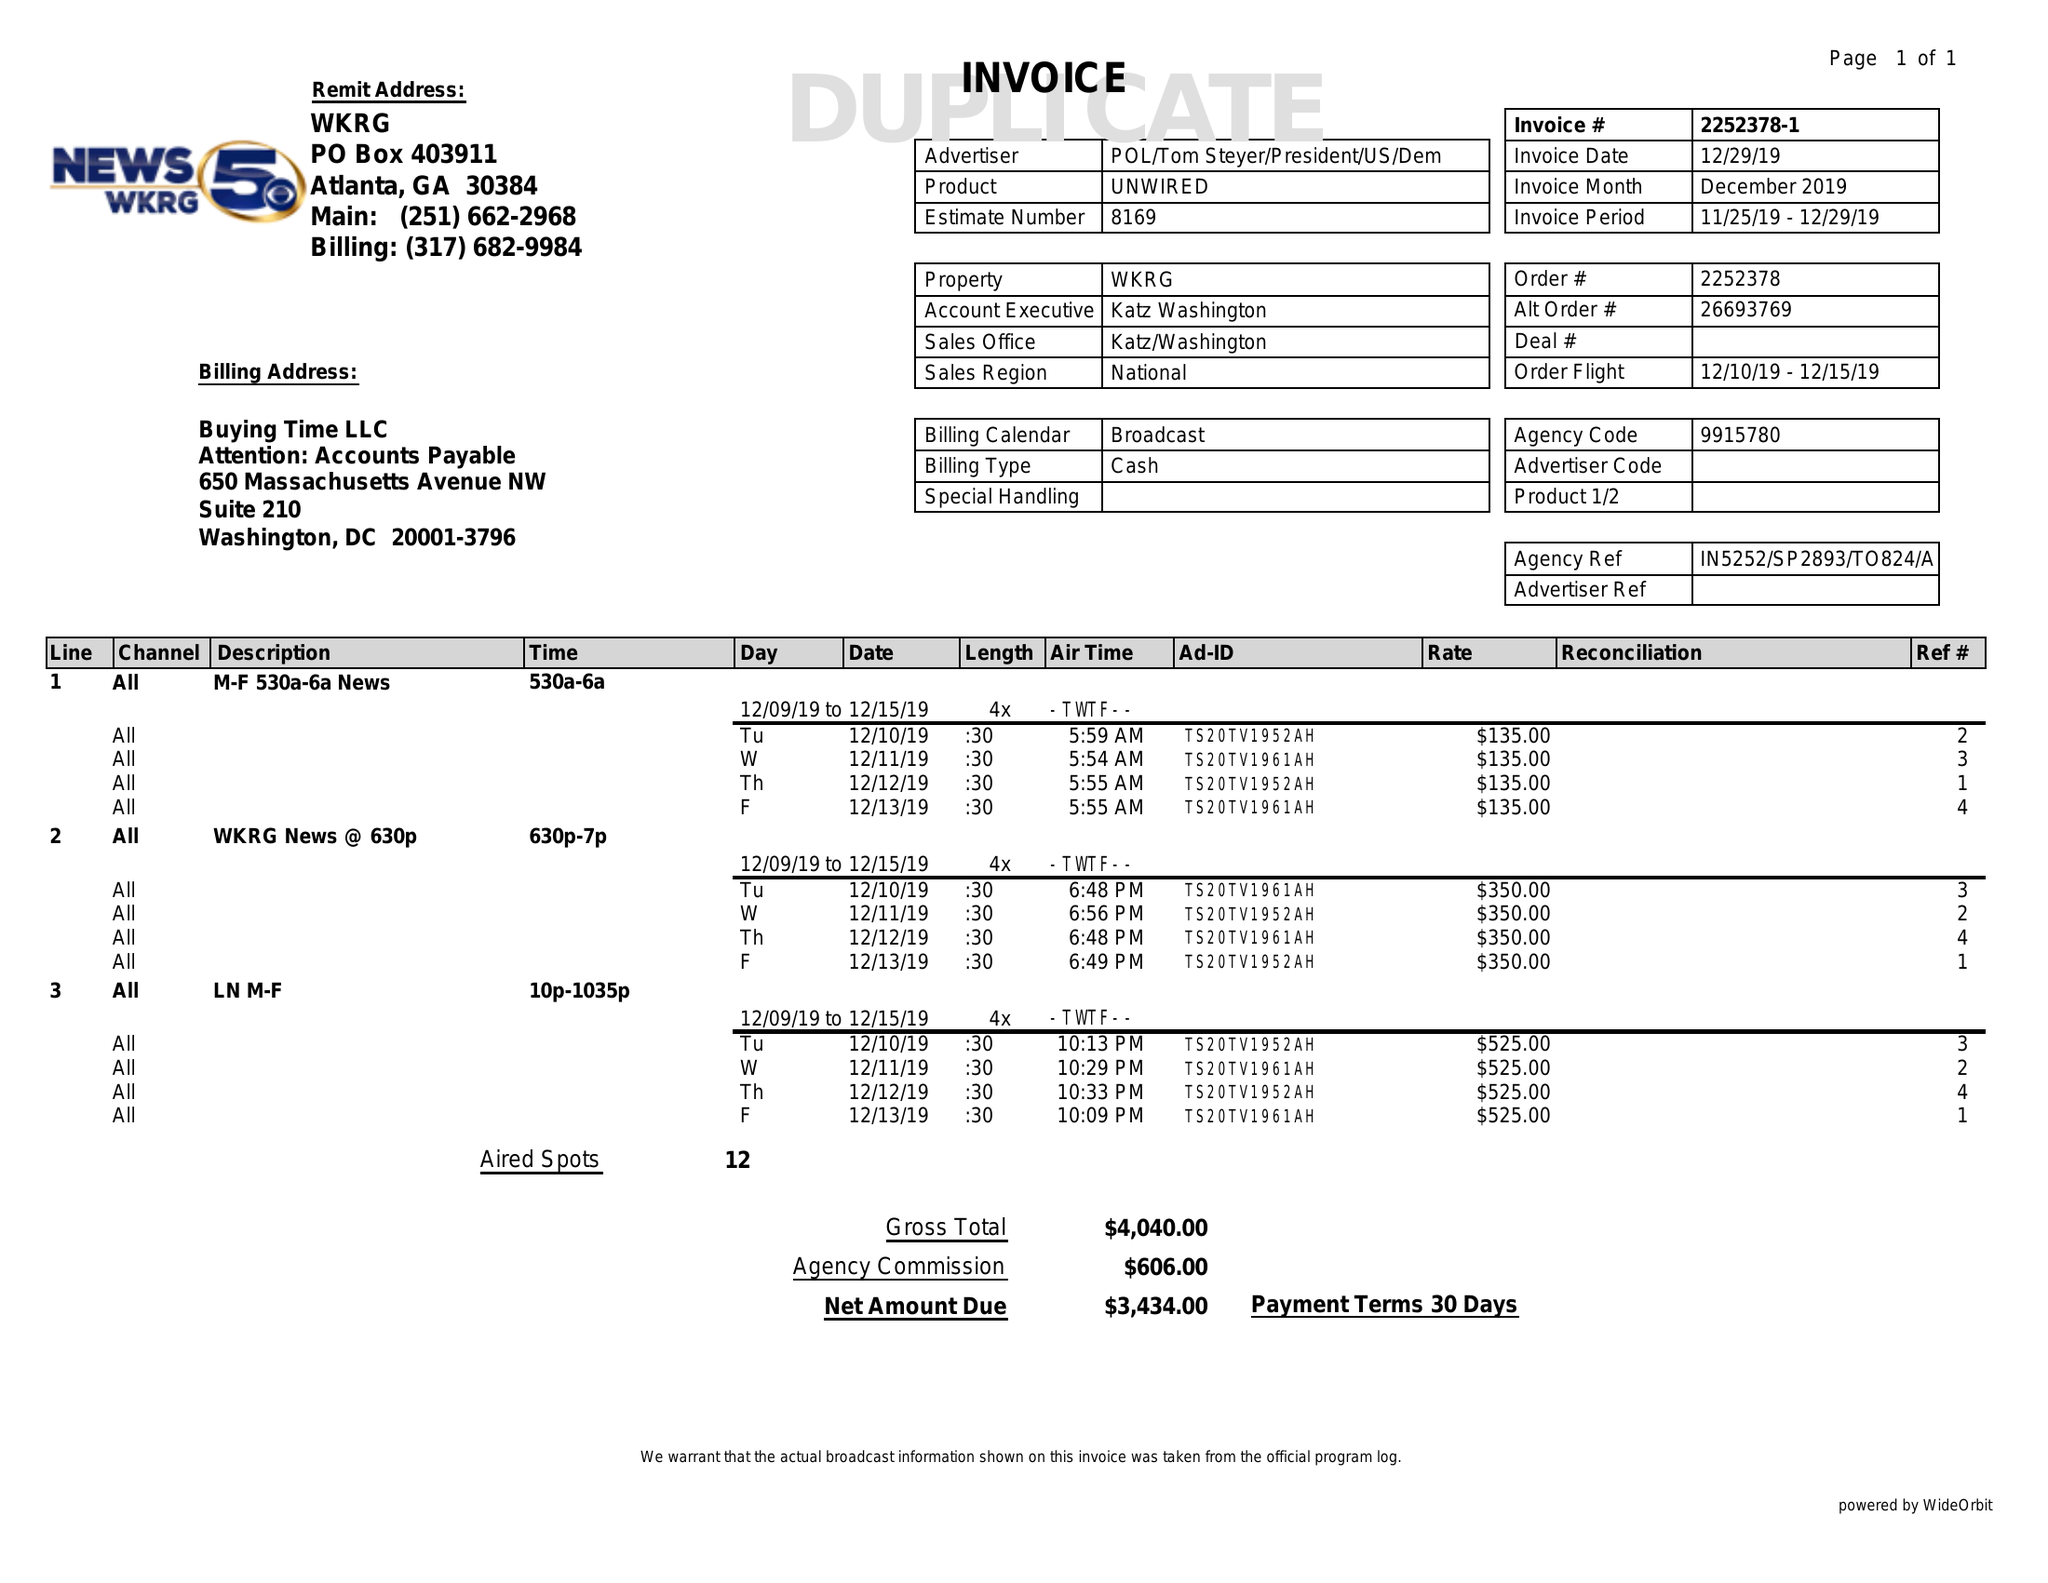What is the value for the contract_num?
Answer the question using a single word or phrase. 2252378 